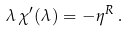Convert formula to latex. <formula><loc_0><loc_0><loc_500><loc_500>\lambda \, \chi ^ { \prime } ( \lambda ) = - \eta ^ { R } \, .</formula> 